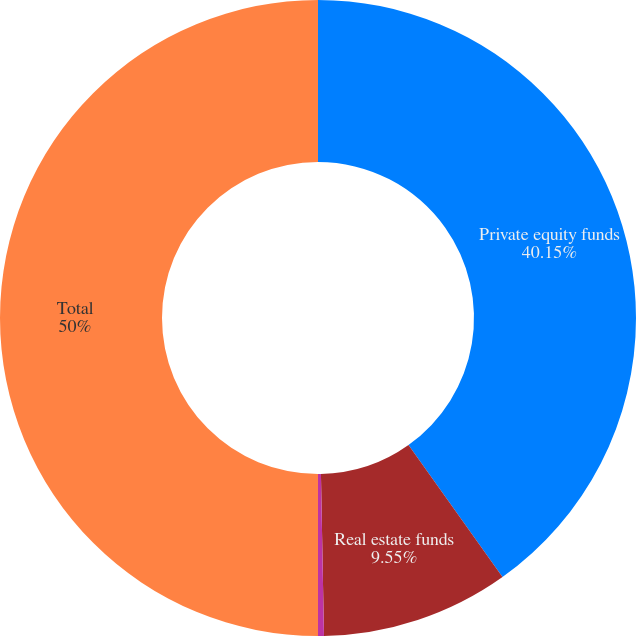Convert chart. <chart><loc_0><loc_0><loc_500><loc_500><pie_chart><fcel>Private equity funds<fcel>Real estate funds<fcel>Multi-strategy hedge funds<fcel>Total<nl><fcel>40.15%<fcel>9.55%<fcel>0.3%<fcel>50.0%<nl></chart> 